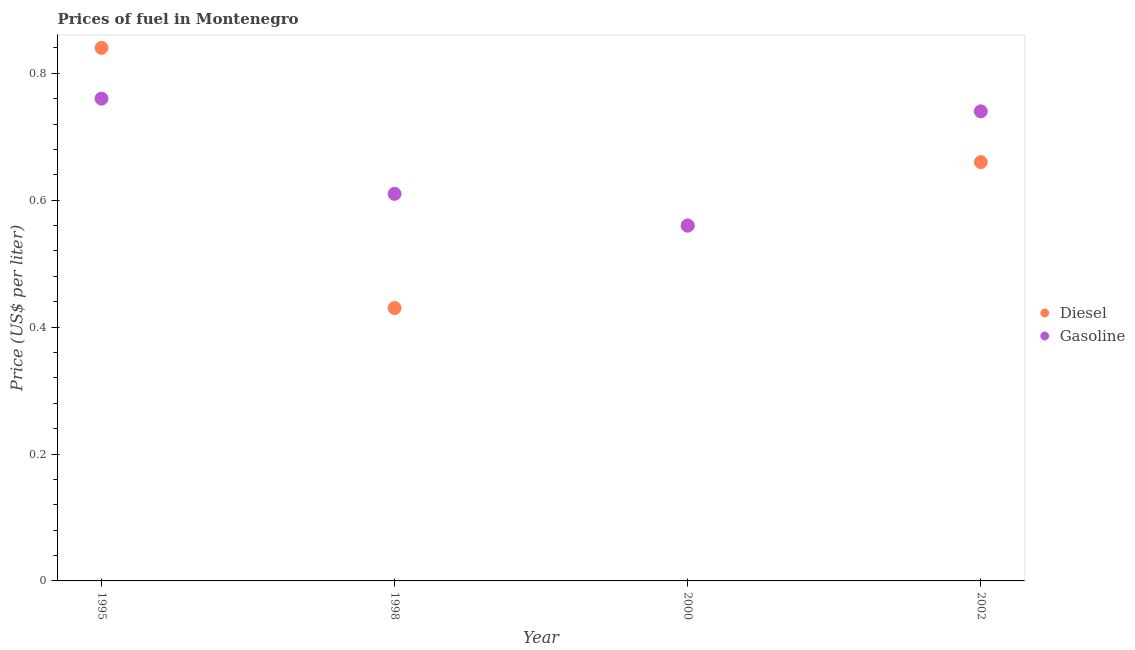What is the gasoline price in 2002?
Your answer should be very brief. 0.74. Across all years, what is the maximum diesel price?
Provide a short and direct response. 0.84. Across all years, what is the minimum diesel price?
Provide a succinct answer. 0.43. What is the total gasoline price in the graph?
Your answer should be compact. 2.67. What is the difference between the diesel price in 2000 and that in 2002?
Provide a succinct answer. -0.1. What is the difference between the gasoline price in 2002 and the diesel price in 1995?
Keep it short and to the point. -0.1. What is the average gasoline price per year?
Offer a very short reply. 0.67. In the year 1998, what is the difference between the diesel price and gasoline price?
Offer a terse response. -0.18. What is the ratio of the diesel price in 1995 to that in 2000?
Give a very brief answer. 1.5. Is the diesel price in 1995 less than that in 2000?
Provide a short and direct response. No. What is the difference between the highest and the second highest diesel price?
Provide a succinct answer. 0.18. What is the difference between the highest and the lowest diesel price?
Your answer should be compact. 0.41. In how many years, is the gasoline price greater than the average gasoline price taken over all years?
Your answer should be compact. 2. Is the sum of the diesel price in 1995 and 1998 greater than the maximum gasoline price across all years?
Provide a succinct answer. Yes. Does the diesel price monotonically increase over the years?
Your response must be concise. No. Is the gasoline price strictly greater than the diesel price over the years?
Your response must be concise. No. How many dotlines are there?
Your answer should be very brief. 2. Are the values on the major ticks of Y-axis written in scientific E-notation?
Offer a terse response. No. Does the graph contain any zero values?
Your answer should be compact. No. How many legend labels are there?
Your answer should be very brief. 2. What is the title of the graph?
Provide a short and direct response. Prices of fuel in Montenegro. Does "Tetanus" appear as one of the legend labels in the graph?
Give a very brief answer. No. What is the label or title of the X-axis?
Keep it short and to the point. Year. What is the label or title of the Y-axis?
Keep it short and to the point. Price (US$ per liter). What is the Price (US$ per liter) of Diesel in 1995?
Make the answer very short. 0.84. What is the Price (US$ per liter) of Gasoline in 1995?
Provide a succinct answer. 0.76. What is the Price (US$ per liter) of Diesel in 1998?
Your answer should be compact. 0.43. What is the Price (US$ per liter) of Gasoline in 1998?
Your answer should be very brief. 0.61. What is the Price (US$ per liter) of Diesel in 2000?
Provide a succinct answer. 0.56. What is the Price (US$ per liter) in Gasoline in 2000?
Ensure brevity in your answer.  0.56. What is the Price (US$ per liter) in Diesel in 2002?
Your response must be concise. 0.66. What is the Price (US$ per liter) in Gasoline in 2002?
Your response must be concise. 0.74. Across all years, what is the maximum Price (US$ per liter) in Diesel?
Ensure brevity in your answer.  0.84. Across all years, what is the maximum Price (US$ per liter) of Gasoline?
Keep it short and to the point. 0.76. Across all years, what is the minimum Price (US$ per liter) of Diesel?
Provide a succinct answer. 0.43. Across all years, what is the minimum Price (US$ per liter) in Gasoline?
Ensure brevity in your answer.  0.56. What is the total Price (US$ per liter) of Diesel in the graph?
Your response must be concise. 2.49. What is the total Price (US$ per liter) in Gasoline in the graph?
Make the answer very short. 2.67. What is the difference between the Price (US$ per liter) in Diesel in 1995 and that in 1998?
Offer a terse response. 0.41. What is the difference between the Price (US$ per liter) of Gasoline in 1995 and that in 1998?
Offer a very short reply. 0.15. What is the difference between the Price (US$ per liter) in Diesel in 1995 and that in 2000?
Ensure brevity in your answer.  0.28. What is the difference between the Price (US$ per liter) in Gasoline in 1995 and that in 2000?
Ensure brevity in your answer.  0.2. What is the difference between the Price (US$ per liter) of Diesel in 1995 and that in 2002?
Provide a succinct answer. 0.18. What is the difference between the Price (US$ per liter) of Diesel in 1998 and that in 2000?
Offer a very short reply. -0.13. What is the difference between the Price (US$ per liter) of Gasoline in 1998 and that in 2000?
Make the answer very short. 0.05. What is the difference between the Price (US$ per liter) of Diesel in 1998 and that in 2002?
Make the answer very short. -0.23. What is the difference between the Price (US$ per liter) in Gasoline in 1998 and that in 2002?
Make the answer very short. -0.13. What is the difference between the Price (US$ per liter) of Diesel in 2000 and that in 2002?
Keep it short and to the point. -0.1. What is the difference between the Price (US$ per liter) in Gasoline in 2000 and that in 2002?
Give a very brief answer. -0.18. What is the difference between the Price (US$ per liter) of Diesel in 1995 and the Price (US$ per liter) of Gasoline in 1998?
Provide a succinct answer. 0.23. What is the difference between the Price (US$ per liter) in Diesel in 1995 and the Price (US$ per liter) in Gasoline in 2000?
Make the answer very short. 0.28. What is the difference between the Price (US$ per liter) of Diesel in 1998 and the Price (US$ per liter) of Gasoline in 2000?
Provide a succinct answer. -0.13. What is the difference between the Price (US$ per liter) in Diesel in 1998 and the Price (US$ per liter) in Gasoline in 2002?
Your answer should be compact. -0.31. What is the difference between the Price (US$ per liter) in Diesel in 2000 and the Price (US$ per liter) in Gasoline in 2002?
Offer a very short reply. -0.18. What is the average Price (US$ per liter) in Diesel per year?
Give a very brief answer. 0.62. What is the average Price (US$ per liter) of Gasoline per year?
Your answer should be very brief. 0.67. In the year 1995, what is the difference between the Price (US$ per liter) of Diesel and Price (US$ per liter) of Gasoline?
Ensure brevity in your answer.  0.08. In the year 1998, what is the difference between the Price (US$ per liter) of Diesel and Price (US$ per liter) of Gasoline?
Offer a terse response. -0.18. In the year 2000, what is the difference between the Price (US$ per liter) in Diesel and Price (US$ per liter) in Gasoline?
Provide a short and direct response. 0. In the year 2002, what is the difference between the Price (US$ per liter) in Diesel and Price (US$ per liter) in Gasoline?
Give a very brief answer. -0.08. What is the ratio of the Price (US$ per liter) of Diesel in 1995 to that in 1998?
Your response must be concise. 1.95. What is the ratio of the Price (US$ per liter) of Gasoline in 1995 to that in 1998?
Your response must be concise. 1.25. What is the ratio of the Price (US$ per liter) of Diesel in 1995 to that in 2000?
Keep it short and to the point. 1.5. What is the ratio of the Price (US$ per liter) in Gasoline in 1995 to that in 2000?
Provide a short and direct response. 1.36. What is the ratio of the Price (US$ per liter) in Diesel in 1995 to that in 2002?
Provide a short and direct response. 1.27. What is the ratio of the Price (US$ per liter) in Diesel in 1998 to that in 2000?
Ensure brevity in your answer.  0.77. What is the ratio of the Price (US$ per liter) in Gasoline in 1998 to that in 2000?
Provide a succinct answer. 1.09. What is the ratio of the Price (US$ per liter) of Diesel in 1998 to that in 2002?
Give a very brief answer. 0.65. What is the ratio of the Price (US$ per liter) in Gasoline in 1998 to that in 2002?
Give a very brief answer. 0.82. What is the ratio of the Price (US$ per liter) of Diesel in 2000 to that in 2002?
Ensure brevity in your answer.  0.85. What is the ratio of the Price (US$ per liter) of Gasoline in 2000 to that in 2002?
Offer a very short reply. 0.76. What is the difference between the highest and the second highest Price (US$ per liter) of Diesel?
Your answer should be very brief. 0.18. What is the difference between the highest and the second highest Price (US$ per liter) of Gasoline?
Offer a very short reply. 0.02. What is the difference between the highest and the lowest Price (US$ per liter) of Diesel?
Your answer should be compact. 0.41. What is the difference between the highest and the lowest Price (US$ per liter) in Gasoline?
Ensure brevity in your answer.  0.2. 